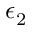Convert formula to latex. <formula><loc_0><loc_0><loc_500><loc_500>\epsilon _ { 2 }</formula> 